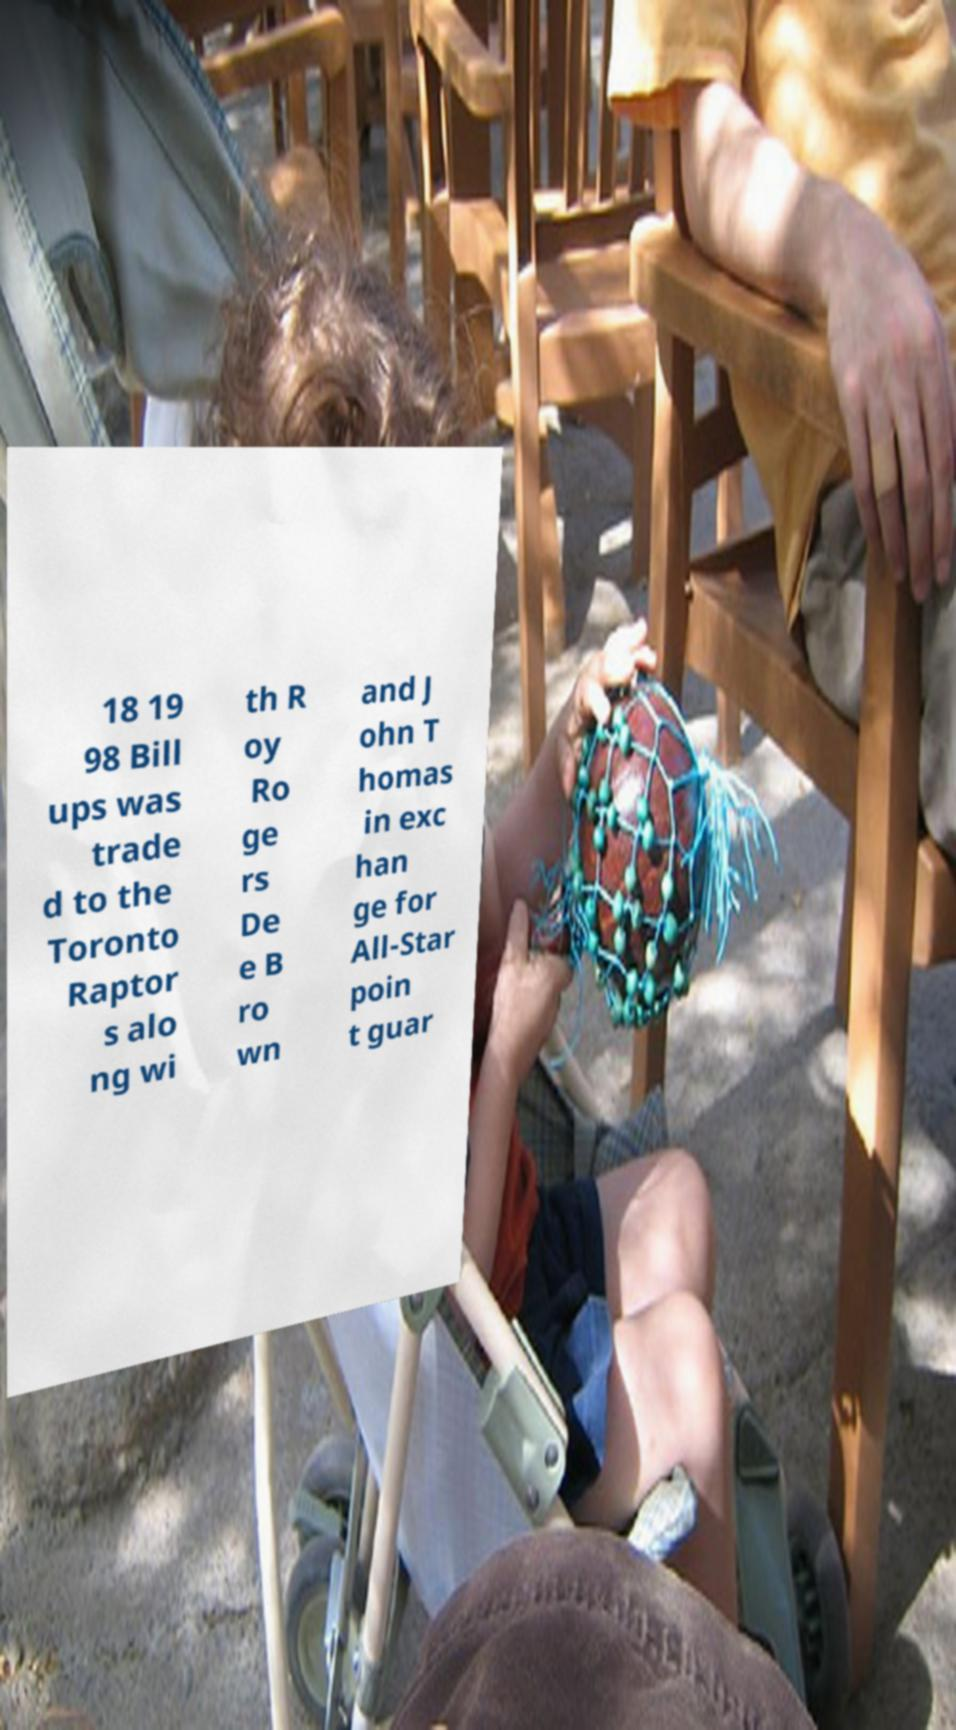Can you accurately transcribe the text from the provided image for me? 18 19 98 Bill ups was trade d to the Toronto Raptor s alo ng wi th R oy Ro ge rs De e B ro wn and J ohn T homas in exc han ge for All-Star poin t guar 